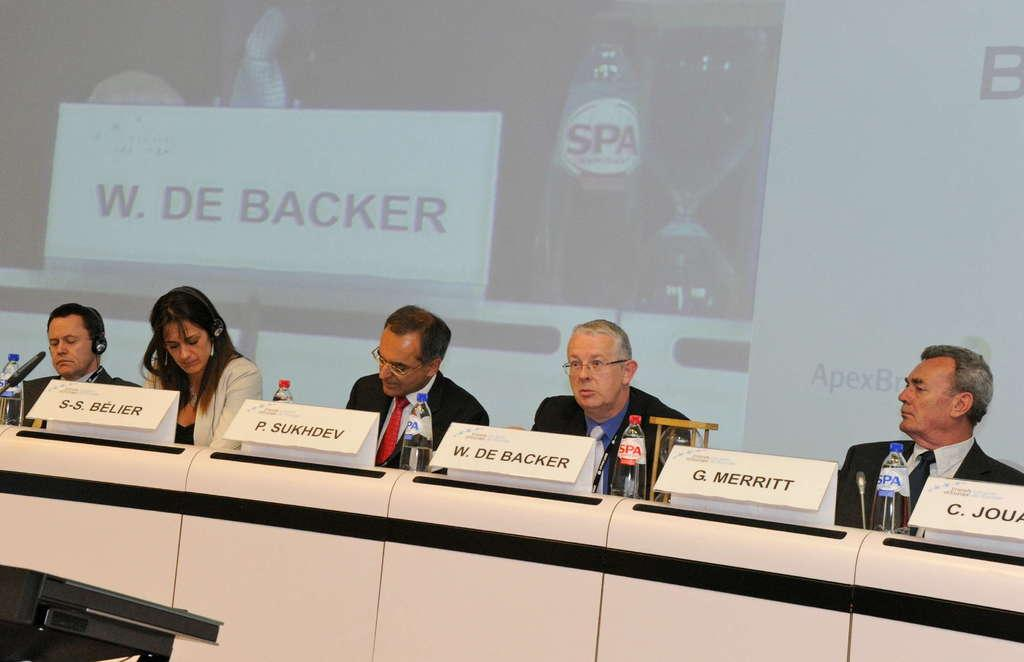How many people are present in the image? There are five people in the image. What objects can be seen in the image besides the people? There are bottles, microphones, name boards, and other objects in the image. What might be used for amplifying sound in the image? Microphones (mics) are present in the image for amplifying sound. What is visible in the background of the image? There is a screen visible in the background of the image. What type of knife is being used to mine in the image? There is no knife or mining activity present in the image. 